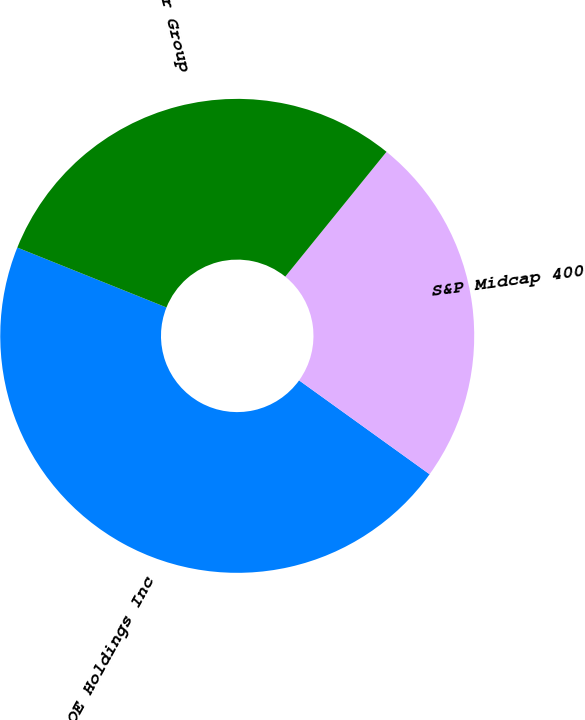Convert chart. <chart><loc_0><loc_0><loc_500><loc_500><pie_chart><fcel>CBOE Holdings Inc<fcel>S&P Midcap 400<fcel>Peer Group<nl><fcel>46.15%<fcel>24.08%<fcel>29.77%<nl></chart> 